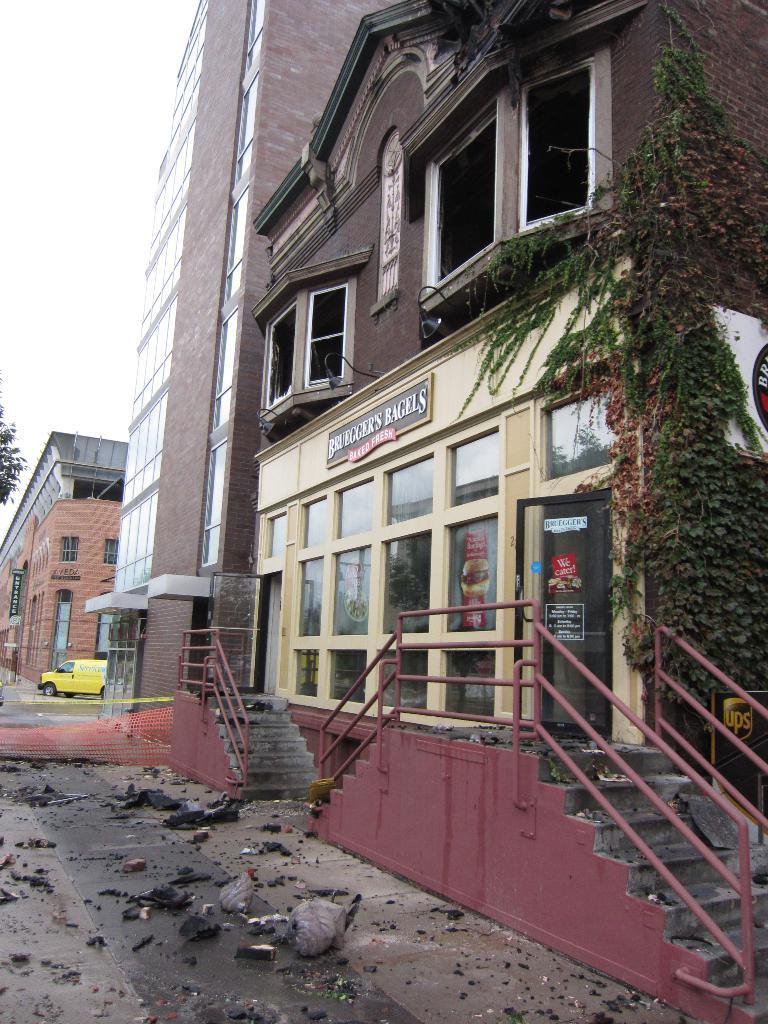Please provide a concise description of this image. In the foreground of the image we can see the road and some broken objects are there on the road and some steps are there. In the middle of the image we can see buildings and a van. On the top of the image we can see the sky. 